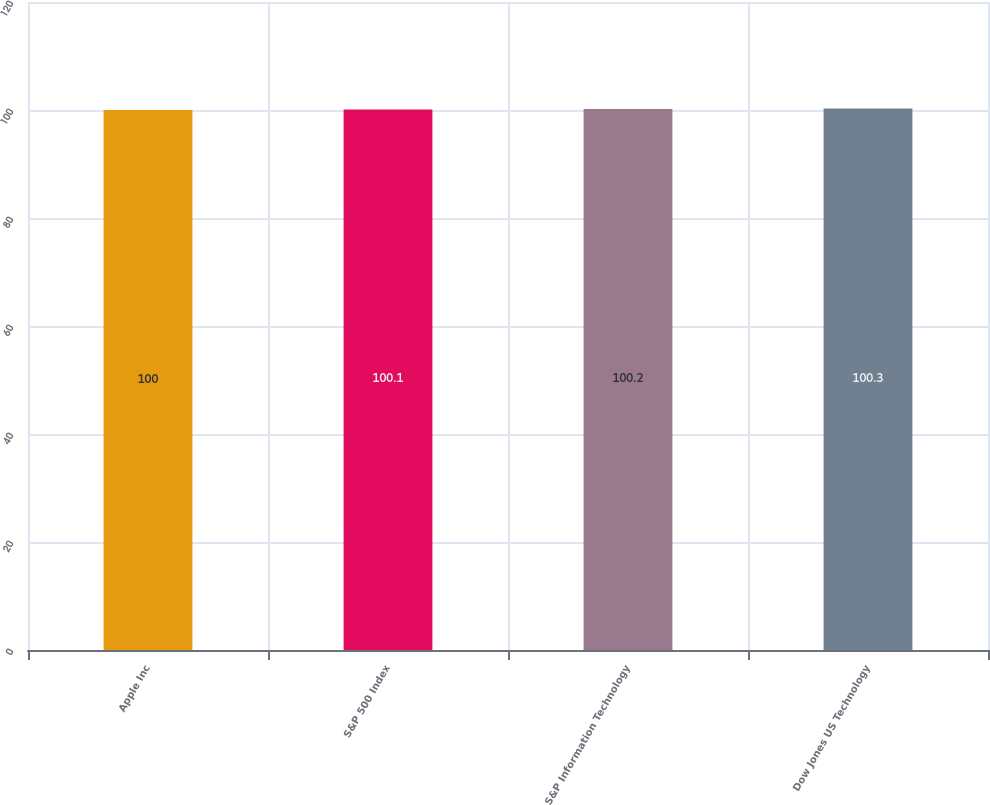<chart> <loc_0><loc_0><loc_500><loc_500><bar_chart><fcel>Apple Inc<fcel>S&P 500 Index<fcel>S&P Information Technology<fcel>Dow Jones US Technology<nl><fcel>100<fcel>100.1<fcel>100.2<fcel>100.3<nl></chart> 